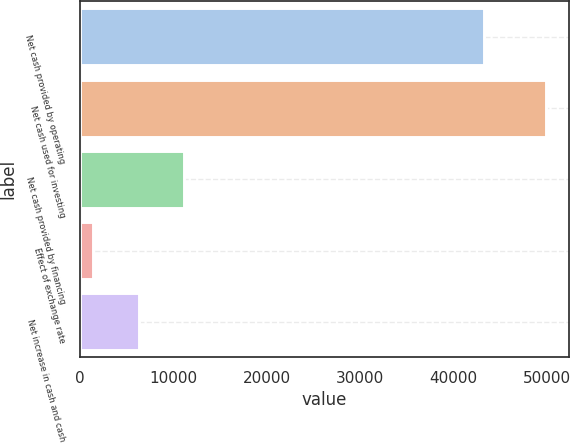Convert chart. <chart><loc_0><loc_0><loc_500><loc_500><bar_chart><fcel>Net cash provided by operating<fcel>Net cash used for investing<fcel>Net cash provided by financing<fcel>Effect of exchange rate<fcel>Net increase in cash and cash<nl><fcel>43290<fcel>49863<fcel>11144.6<fcel>1465<fcel>6304.8<nl></chart> 